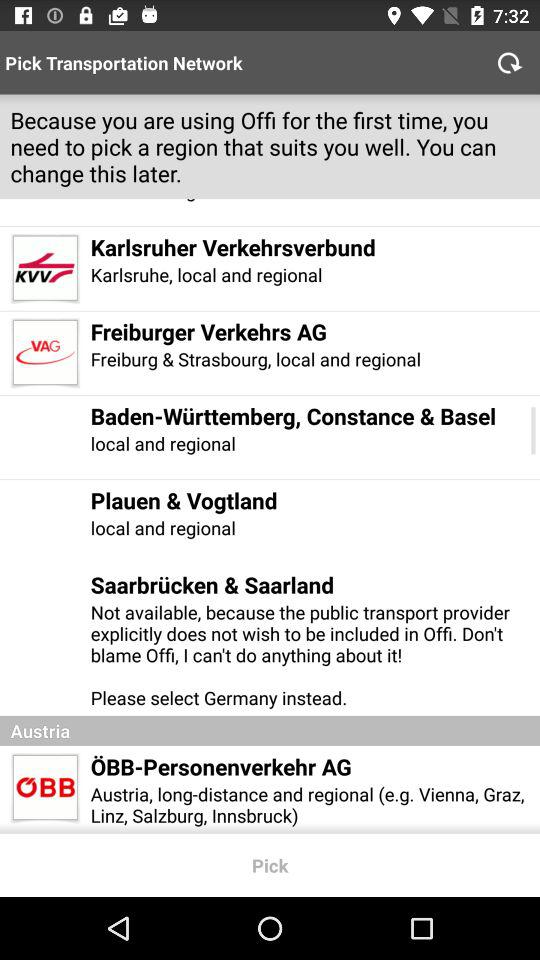What is the name of the company that comes under Austria? The name of the company is "ÖBB-Personenverkehr AG". 